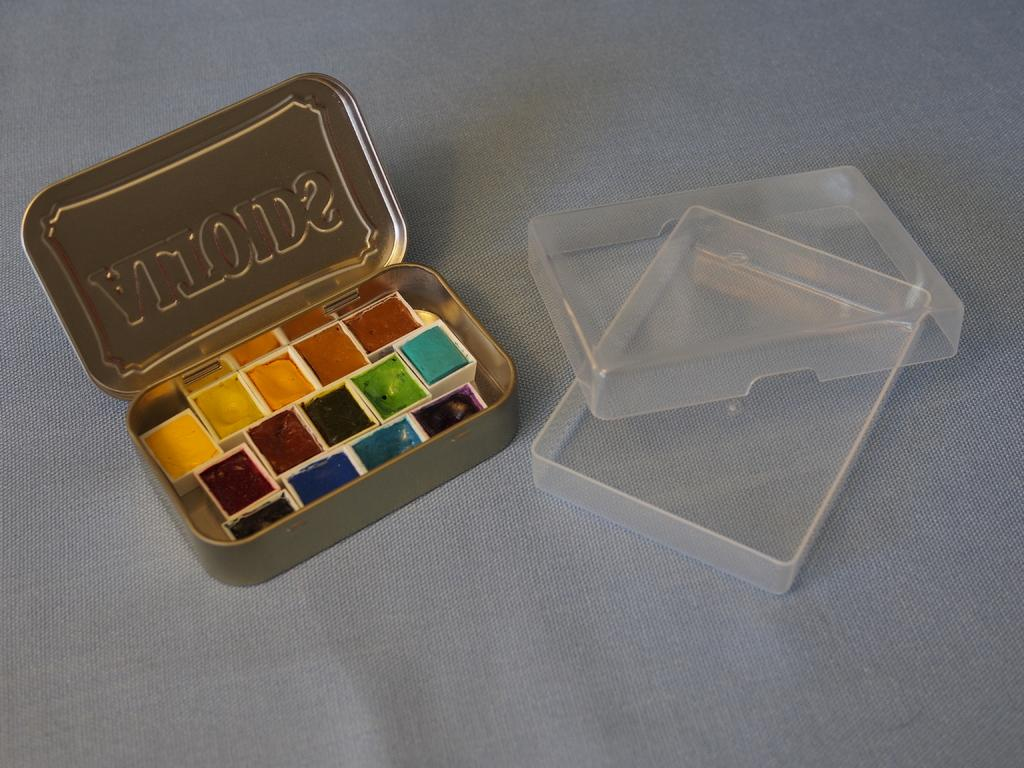Provide a one-sentence caption for the provided image. Small samples of colored paints inside tiny containers in an Altoids tin. 